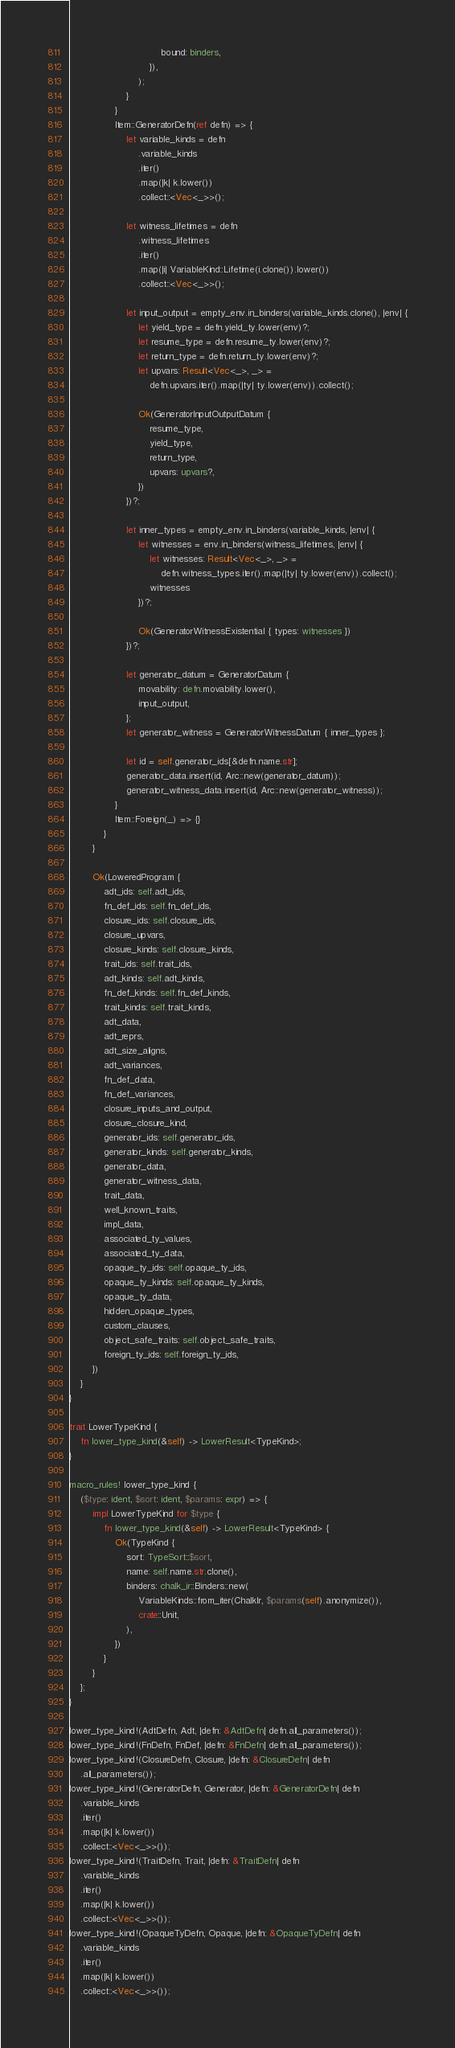<code> <loc_0><loc_0><loc_500><loc_500><_Rust_>                                bound: binders,
                            }),
                        );
                    }
                }
                Item::GeneratorDefn(ref defn) => {
                    let variable_kinds = defn
                        .variable_kinds
                        .iter()
                        .map(|k| k.lower())
                        .collect::<Vec<_>>();

                    let witness_lifetimes = defn
                        .witness_lifetimes
                        .iter()
                        .map(|i| VariableKind::Lifetime(i.clone()).lower())
                        .collect::<Vec<_>>();

                    let input_output = empty_env.in_binders(variable_kinds.clone(), |env| {
                        let yield_type = defn.yield_ty.lower(env)?;
                        let resume_type = defn.resume_ty.lower(env)?;
                        let return_type = defn.return_ty.lower(env)?;
                        let upvars: Result<Vec<_>, _> =
                            defn.upvars.iter().map(|ty| ty.lower(env)).collect();

                        Ok(GeneratorInputOutputDatum {
                            resume_type,
                            yield_type,
                            return_type,
                            upvars: upvars?,
                        })
                    })?;

                    let inner_types = empty_env.in_binders(variable_kinds, |env| {
                        let witnesses = env.in_binders(witness_lifetimes, |env| {
                            let witnesses: Result<Vec<_>, _> =
                                defn.witness_types.iter().map(|ty| ty.lower(env)).collect();
                            witnesses
                        })?;

                        Ok(GeneratorWitnessExistential { types: witnesses })
                    })?;

                    let generator_datum = GeneratorDatum {
                        movability: defn.movability.lower(),
                        input_output,
                    };
                    let generator_witness = GeneratorWitnessDatum { inner_types };

                    let id = self.generator_ids[&defn.name.str];
                    generator_data.insert(id, Arc::new(generator_datum));
                    generator_witness_data.insert(id, Arc::new(generator_witness));
                }
                Item::Foreign(_) => {}
            }
        }

        Ok(LoweredProgram {
            adt_ids: self.adt_ids,
            fn_def_ids: self.fn_def_ids,
            closure_ids: self.closure_ids,
            closure_upvars,
            closure_kinds: self.closure_kinds,
            trait_ids: self.trait_ids,
            adt_kinds: self.adt_kinds,
            fn_def_kinds: self.fn_def_kinds,
            trait_kinds: self.trait_kinds,
            adt_data,
            adt_reprs,
            adt_size_aligns,
            adt_variances,
            fn_def_data,
            fn_def_variances,
            closure_inputs_and_output,
            closure_closure_kind,
            generator_ids: self.generator_ids,
            generator_kinds: self.generator_kinds,
            generator_data,
            generator_witness_data,
            trait_data,
            well_known_traits,
            impl_data,
            associated_ty_values,
            associated_ty_data,
            opaque_ty_ids: self.opaque_ty_ids,
            opaque_ty_kinds: self.opaque_ty_kinds,
            opaque_ty_data,
            hidden_opaque_types,
            custom_clauses,
            object_safe_traits: self.object_safe_traits,
            foreign_ty_ids: self.foreign_ty_ids,
        })
    }
}

trait LowerTypeKind {
    fn lower_type_kind(&self) -> LowerResult<TypeKind>;
}

macro_rules! lower_type_kind {
    ($type: ident, $sort: ident, $params: expr) => {
        impl LowerTypeKind for $type {
            fn lower_type_kind(&self) -> LowerResult<TypeKind> {
                Ok(TypeKind {
                    sort: TypeSort::$sort,
                    name: self.name.str.clone(),
                    binders: chalk_ir::Binders::new(
                        VariableKinds::from_iter(ChalkIr, $params(self).anonymize()),
                        crate::Unit,
                    ),
                })
            }
        }
    };
}

lower_type_kind!(AdtDefn, Adt, |defn: &AdtDefn| defn.all_parameters());
lower_type_kind!(FnDefn, FnDef, |defn: &FnDefn| defn.all_parameters());
lower_type_kind!(ClosureDefn, Closure, |defn: &ClosureDefn| defn
    .all_parameters());
lower_type_kind!(GeneratorDefn, Generator, |defn: &GeneratorDefn| defn
    .variable_kinds
    .iter()
    .map(|k| k.lower())
    .collect::<Vec<_>>());
lower_type_kind!(TraitDefn, Trait, |defn: &TraitDefn| defn
    .variable_kinds
    .iter()
    .map(|k| k.lower())
    .collect::<Vec<_>>());
lower_type_kind!(OpaqueTyDefn, Opaque, |defn: &OpaqueTyDefn| defn
    .variable_kinds
    .iter()
    .map(|k| k.lower())
    .collect::<Vec<_>>());
</code> 